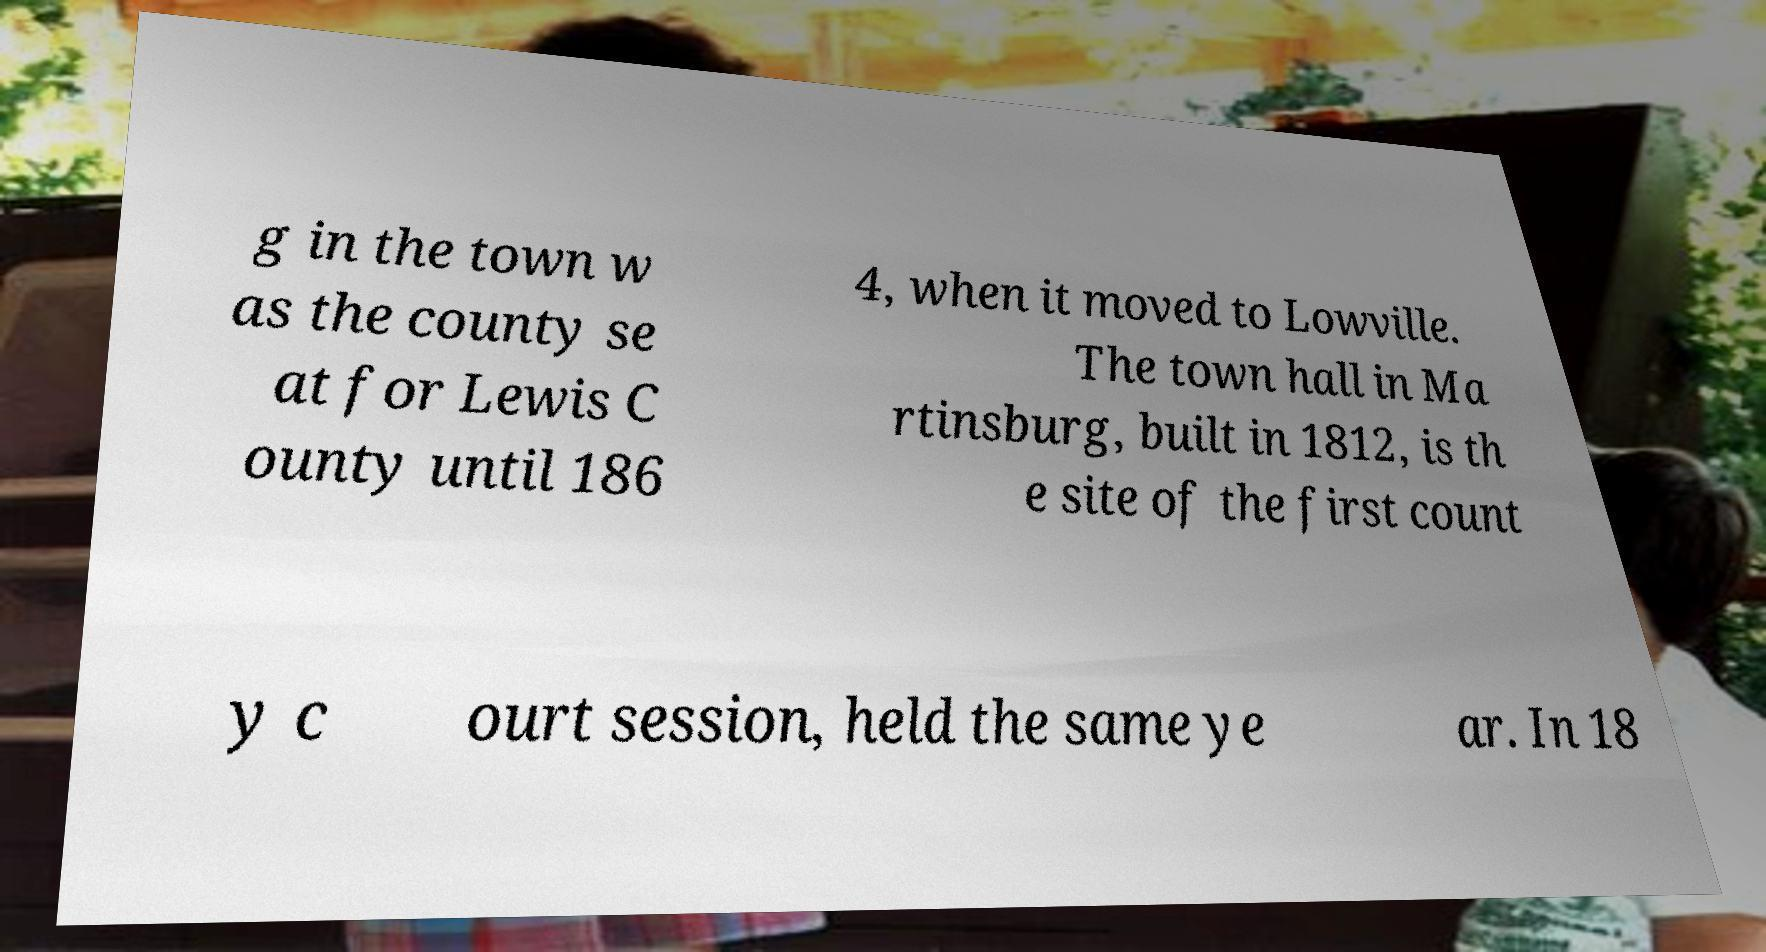What messages or text are displayed in this image? I need them in a readable, typed format. g in the town w as the county se at for Lewis C ounty until 186 4, when it moved to Lowville. The town hall in Ma rtinsburg, built in 1812, is th e site of the first count y c ourt session, held the same ye ar. In 18 